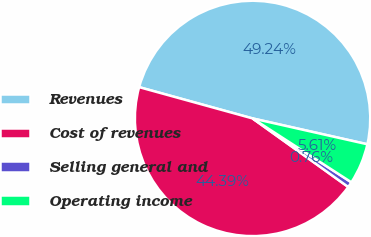<chart> <loc_0><loc_0><loc_500><loc_500><pie_chart><fcel>Revenues<fcel>Cost of revenues<fcel>Selling general and<fcel>Operating income<nl><fcel>49.24%<fcel>44.39%<fcel>0.76%<fcel>5.61%<nl></chart> 